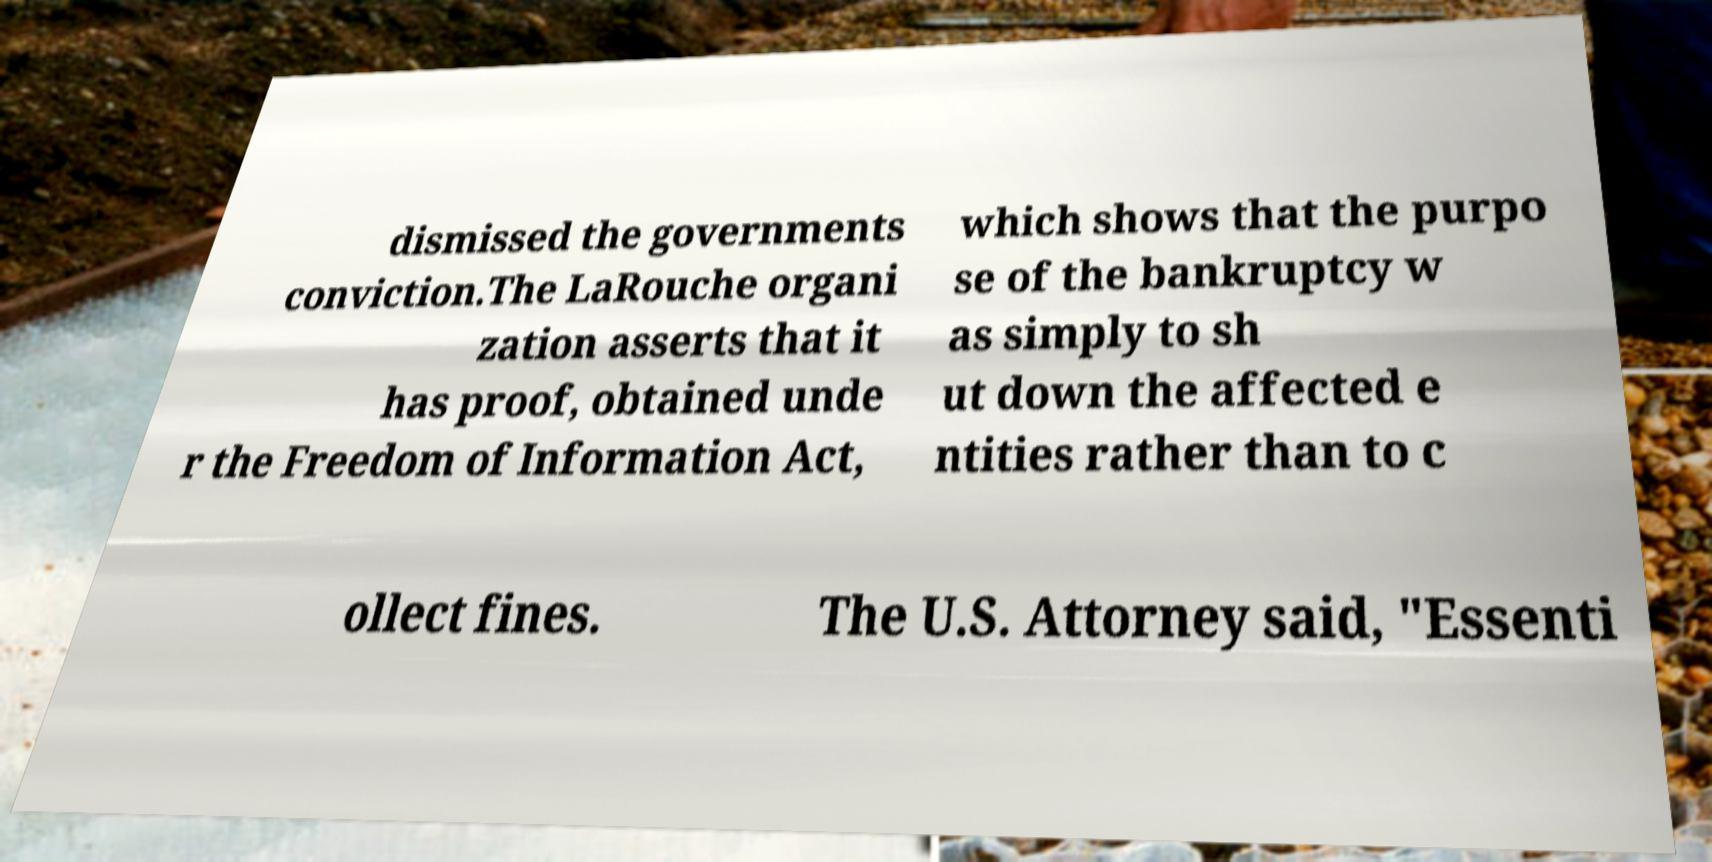I need the written content from this picture converted into text. Can you do that? dismissed the governments conviction.The LaRouche organi zation asserts that it has proof, obtained unde r the Freedom of Information Act, which shows that the purpo se of the bankruptcy w as simply to sh ut down the affected e ntities rather than to c ollect fines. The U.S. Attorney said, "Essenti 